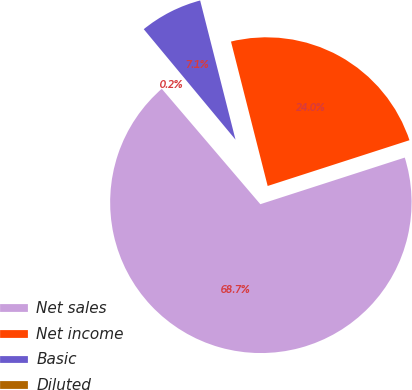Convert chart. <chart><loc_0><loc_0><loc_500><loc_500><pie_chart><fcel>Net sales<fcel>Net income<fcel>Basic<fcel>Diluted<nl><fcel>68.71%<fcel>23.99%<fcel>7.07%<fcel>0.22%<nl></chart> 